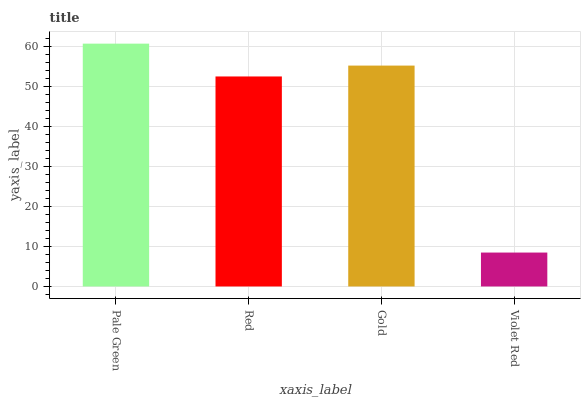Is Violet Red the minimum?
Answer yes or no. Yes. Is Pale Green the maximum?
Answer yes or no. Yes. Is Red the minimum?
Answer yes or no. No. Is Red the maximum?
Answer yes or no. No. Is Pale Green greater than Red?
Answer yes or no. Yes. Is Red less than Pale Green?
Answer yes or no. Yes. Is Red greater than Pale Green?
Answer yes or no. No. Is Pale Green less than Red?
Answer yes or no. No. Is Gold the high median?
Answer yes or no. Yes. Is Red the low median?
Answer yes or no. Yes. Is Pale Green the high median?
Answer yes or no. No. Is Pale Green the low median?
Answer yes or no. No. 